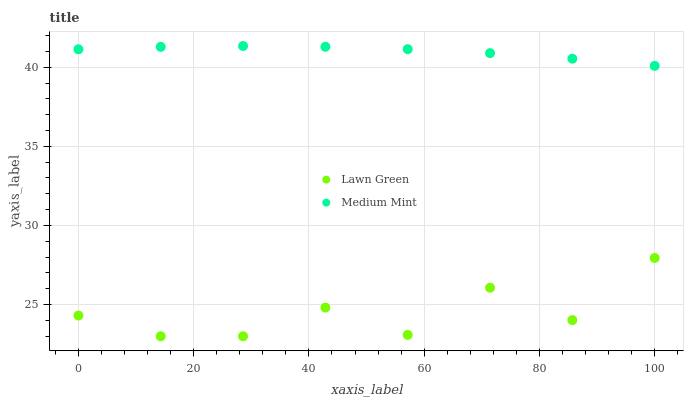Does Lawn Green have the minimum area under the curve?
Answer yes or no. Yes. Does Medium Mint have the maximum area under the curve?
Answer yes or no. Yes. Does Lawn Green have the maximum area under the curve?
Answer yes or no. No. Is Medium Mint the smoothest?
Answer yes or no. Yes. Is Lawn Green the roughest?
Answer yes or no. Yes. Is Lawn Green the smoothest?
Answer yes or no. No. Does Lawn Green have the lowest value?
Answer yes or no. Yes. Does Medium Mint have the highest value?
Answer yes or no. Yes. Does Lawn Green have the highest value?
Answer yes or no. No. Is Lawn Green less than Medium Mint?
Answer yes or no. Yes. Is Medium Mint greater than Lawn Green?
Answer yes or no. Yes. Does Lawn Green intersect Medium Mint?
Answer yes or no. No. 